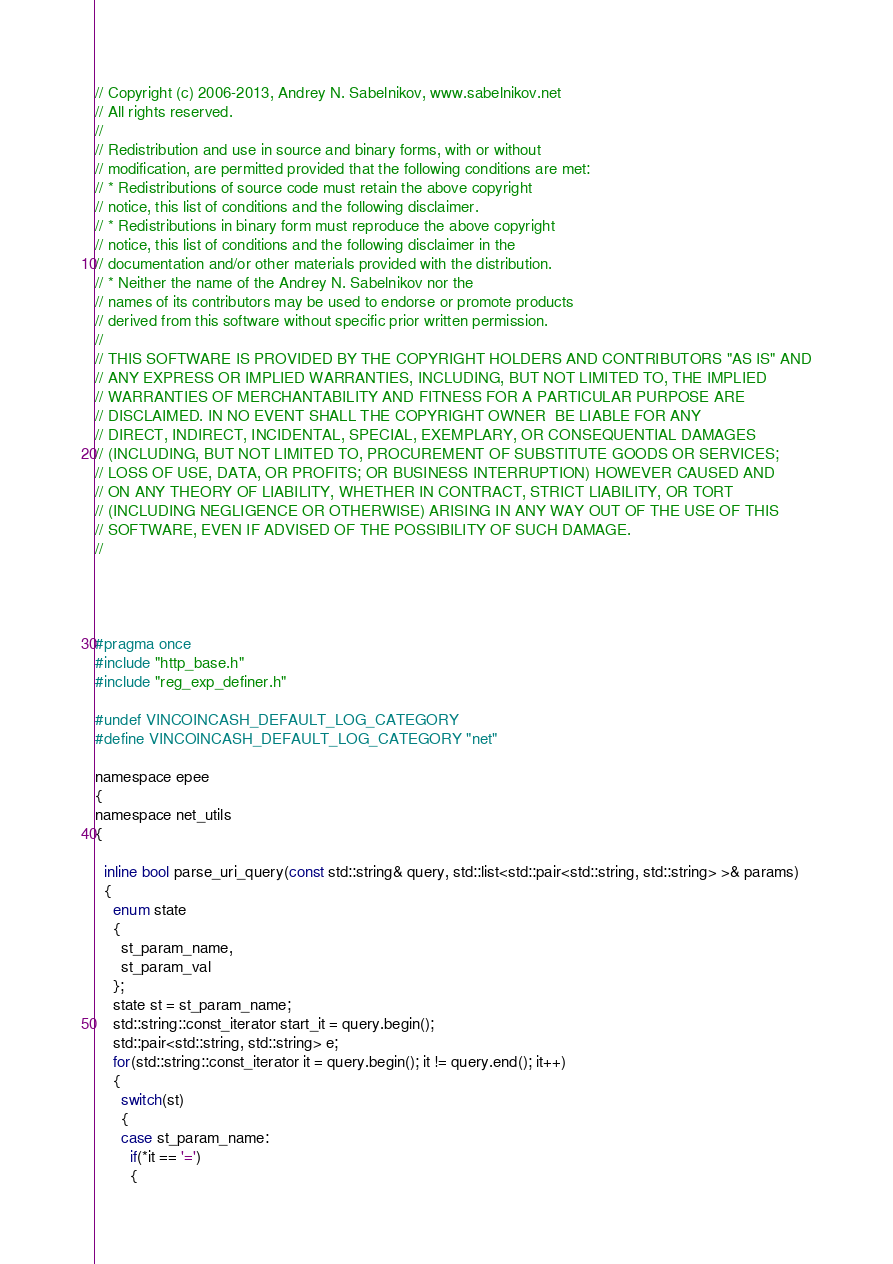<code> <loc_0><loc_0><loc_500><loc_500><_C_>// Copyright (c) 2006-2013, Andrey N. Sabelnikov, www.sabelnikov.net
// All rights reserved.
// 
// Redistribution and use in source and binary forms, with or without
// modification, are permitted provided that the following conditions are met:
// * Redistributions of source code must retain the above copyright
// notice, this list of conditions and the following disclaimer.
// * Redistributions in binary form must reproduce the above copyright
// notice, this list of conditions and the following disclaimer in the
// documentation and/or other materials provided with the distribution.
// * Neither the name of the Andrey N. Sabelnikov nor the
// names of its contributors may be used to endorse or promote products
// derived from this software without specific prior written permission.
// 
// THIS SOFTWARE IS PROVIDED BY THE COPYRIGHT HOLDERS AND CONTRIBUTORS "AS IS" AND
// ANY EXPRESS OR IMPLIED WARRANTIES, INCLUDING, BUT NOT LIMITED TO, THE IMPLIED
// WARRANTIES OF MERCHANTABILITY AND FITNESS FOR A PARTICULAR PURPOSE ARE
// DISCLAIMED. IN NO EVENT SHALL THE COPYRIGHT OWNER  BE LIABLE FOR ANY
// DIRECT, INDIRECT, INCIDENTAL, SPECIAL, EXEMPLARY, OR CONSEQUENTIAL DAMAGES
// (INCLUDING, BUT NOT LIMITED TO, PROCUREMENT OF SUBSTITUTE GOODS OR SERVICES;
// LOSS OF USE, DATA, OR PROFITS; OR BUSINESS INTERRUPTION) HOWEVER CAUSED AND
// ON ANY THEORY OF LIABILITY, WHETHER IN CONTRACT, STRICT LIABILITY, OR TORT
// (INCLUDING NEGLIGENCE OR OTHERWISE) ARISING IN ANY WAY OUT OF THE USE OF THIS
// SOFTWARE, EVEN IF ADVISED OF THE POSSIBILITY OF SUCH DAMAGE.
// 




#pragma once 
#include "http_base.h"
#include "reg_exp_definer.h"

#undef VINCOINCASH_DEFAULT_LOG_CATEGORY
#define VINCOINCASH_DEFAULT_LOG_CATEGORY "net"

namespace epee
{
namespace net_utils
{

  inline bool parse_uri_query(const std::string& query, std::list<std::pair<std::string, std::string> >& params)
  { 
    enum state
    {
      st_param_name, 
      st_param_val
    };
    state st = st_param_name;
    std::string::const_iterator start_it = query.begin();
    std::pair<std::string, std::string> e;
    for(std::string::const_iterator it = query.begin(); it != query.end(); it++)
    {
      switch(st)
      {
      case st_param_name:
        if(*it == '=')
        {</code> 